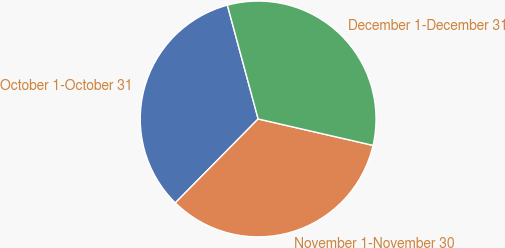<chart> <loc_0><loc_0><loc_500><loc_500><pie_chart><fcel>October 1-October 31<fcel>November 1-November 30<fcel>December 1-December 31<nl><fcel>33.4%<fcel>33.8%<fcel>32.8%<nl></chart> 